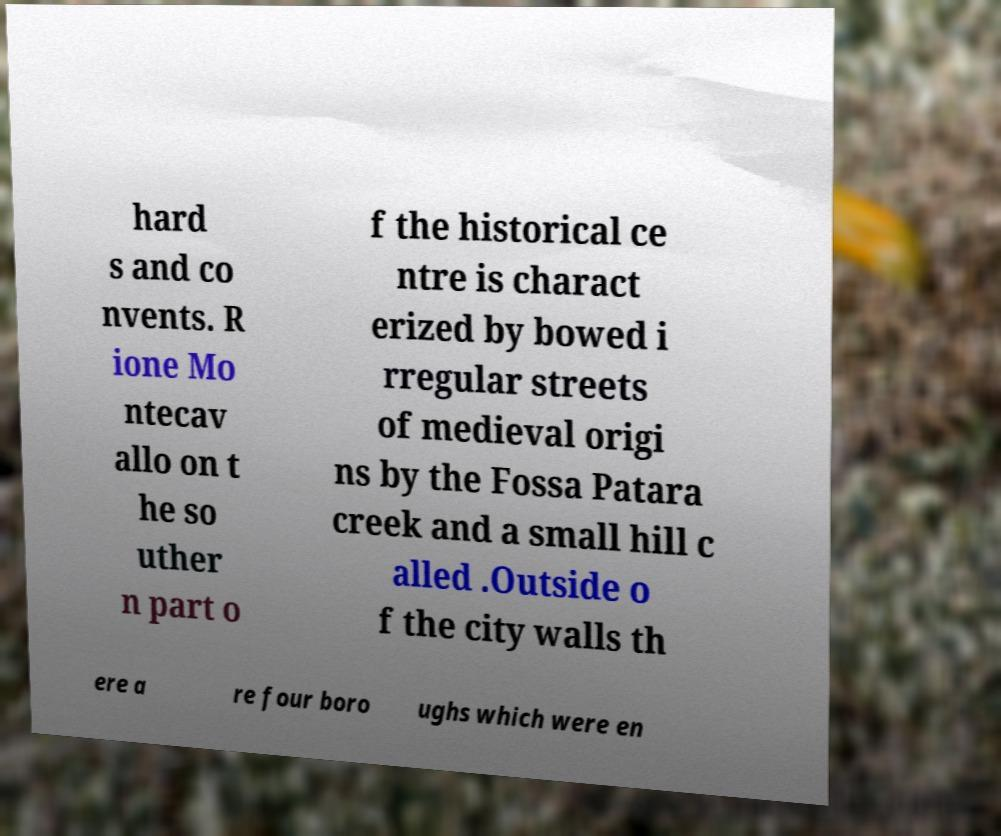I need the written content from this picture converted into text. Can you do that? hard s and co nvents. R ione Mo ntecav allo on t he so uther n part o f the historical ce ntre is charact erized by bowed i rregular streets of medieval origi ns by the Fossa Patara creek and a small hill c alled .Outside o f the city walls th ere a re four boro ughs which were en 